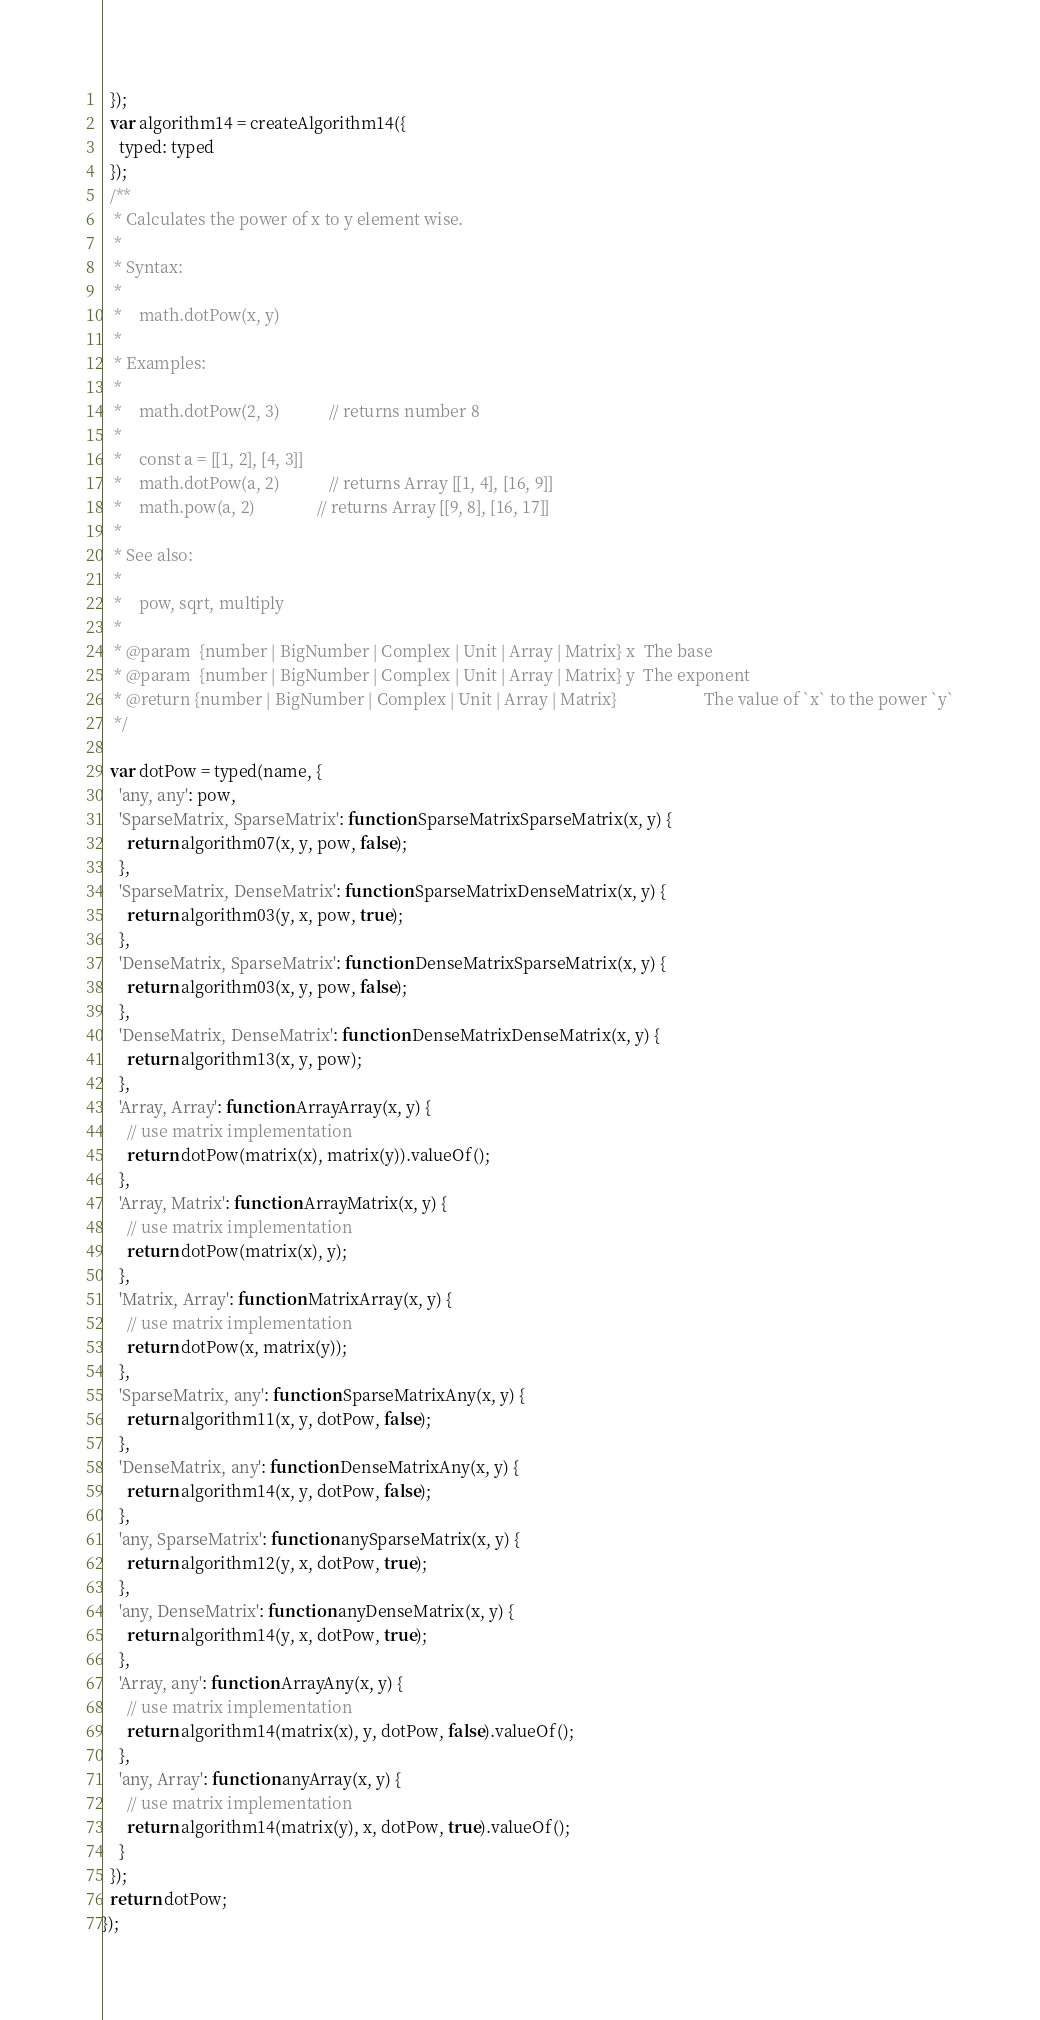Convert code to text. <code><loc_0><loc_0><loc_500><loc_500><_JavaScript_>  });
  var algorithm14 = createAlgorithm14({
    typed: typed
  });
  /**
   * Calculates the power of x to y element wise.
   *
   * Syntax:
   *
   *    math.dotPow(x, y)
   *
   * Examples:
   *
   *    math.dotPow(2, 3)            // returns number 8
   *
   *    const a = [[1, 2], [4, 3]]
   *    math.dotPow(a, 2)            // returns Array [[1, 4], [16, 9]]
   *    math.pow(a, 2)               // returns Array [[9, 8], [16, 17]]
   *
   * See also:
   *
   *    pow, sqrt, multiply
   *
   * @param  {number | BigNumber | Complex | Unit | Array | Matrix} x  The base
   * @param  {number | BigNumber | Complex | Unit | Array | Matrix} y  The exponent
   * @return {number | BigNumber | Complex | Unit | Array | Matrix}                     The value of `x` to the power `y`
   */

  var dotPow = typed(name, {
    'any, any': pow,
    'SparseMatrix, SparseMatrix': function SparseMatrixSparseMatrix(x, y) {
      return algorithm07(x, y, pow, false);
    },
    'SparseMatrix, DenseMatrix': function SparseMatrixDenseMatrix(x, y) {
      return algorithm03(y, x, pow, true);
    },
    'DenseMatrix, SparseMatrix': function DenseMatrixSparseMatrix(x, y) {
      return algorithm03(x, y, pow, false);
    },
    'DenseMatrix, DenseMatrix': function DenseMatrixDenseMatrix(x, y) {
      return algorithm13(x, y, pow);
    },
    'Array, Array': function ArrayArray(x, y) {
      // use matrix implementation
      return dotPow(matrix(x), matrix(y)).valueOf();
    },
    'Array, Matrix': function ArrayMatrix(x, y) {
      // use matrix implementation
      return dotPow(matrix(x), y);
    },
    'Matrix, Array': function MatrixArray(x, y) {
      // use matrix implementation
      return dotPow(x, matrix(y));
    },
    'SparseMatrix, any': function SparseMatrixAny(x, y) {
      return algorithm11(x, y, dotPow, false);
    },
    'DenseMatrix, any': function DenseMatrixAny(x, y) {
      return algorithm14(x, y, dotPow, false);
    },
    'any, SparseMatrix': function anySparseMatrix(x, y) {
      return algorithm12(y, x, dotPow, true);
    },
    'any, DenseMatrix': function anyDenseMatrix(x, y) {
      return algorithm14(y, x, dotPow, true);
    },
    'Array, any': function ArrayAny(x, y) {
      // use matrix implementation
      return algorithm14(matrix(x), y, dotPow, false).valueOf();
    },
    'any, Array': function anyArray(x, y) {
      // use matrix implementation
      return algorithm14(matrix(y), x, dotPow, true).valueOf();
    }
  });
  return dotPow;
});</code> 